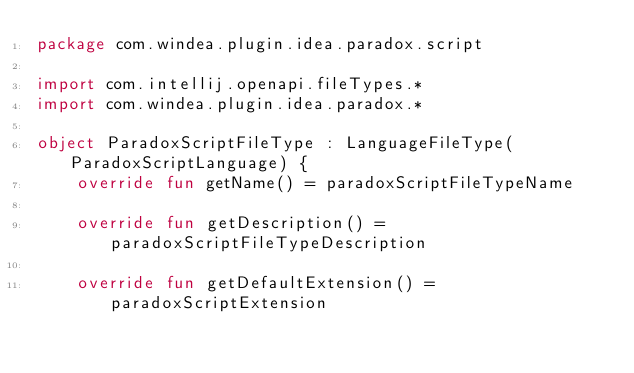<code> <loc_0><loc_0><loc_500><loc_500><_Kotlin_>package com.windea.plugin.idea.paradox.script

import com.intellij.openapi.fileTypes.*
import com.windea.plugin.idea.paradox.*

object ParadoxScriptFileType : LanguageFileType(ParadoxScriptLanguage) {
	override fun getName() = paradoxScriptFileTypeName

	override fun getDescription() = paradoxScriptFileTypeDescription

	override fun getDefaultExtension() = paradoxScriptExtension
</code> 